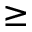Convert formula to latex. <formula><loc_0><loc_0><loc_500><loc_500>\geq</formula> 